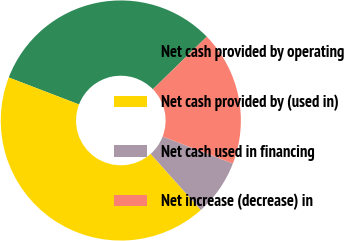Convert chart. <chart><loc_0><loc_0><loc_500><loc_500><pie_chart><fcel>Net cash provided by operating<fcel>Net cash provided by (used in)<fcel>Net cash used in financing<fcel>Net increase (decrease) in<nl><fcel>31.87%<fcel>42.45%<fcel>7.55%<fcel>18.13%<nl></chart> 